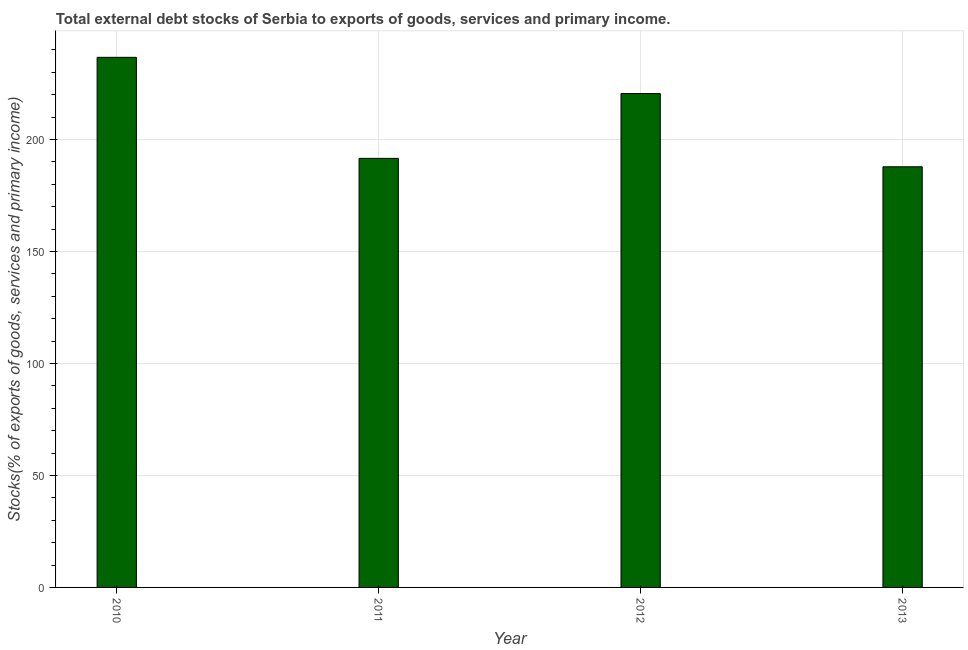Does the graph contain grids?
Give a very brief answer. Yes. What is the title of the graph?
Offer a very short reply. Total external debt stocks of Serbia to exports of goods, services and primary income. What is the label or title of the Y-axis?
Ensure brevity in your answer.  Stocks(% of exports of goods, services and primary income). What is the external debt stocks in 2013?
Offer a terse response. 187.8. Across all years, what is the maximum external debt stocks?
Keep it short and to the point. 236.67. Across all years, what is the minimum external debt stocks?
Provide a succinct answer. 187.8. In which year was the external debt stocks maximum?
Make the answer very short. 2010. What is the sum of the external debt stocks?
Provide a short and direct response. 836.52. What is the difference between the external debt stocks in 2010 and 2013?
Give a very brief answer. 48.87. What is the average external debt stocks per year?
Give a very brief answer. 209.13. What is the median external debt stocks?
Offer a terse response. 206.03. What is the ratio of the external debt stocks in 2010 to that in 2013?
Provide a succinct answer. 1.26. Is the external debt stocks in 2010 less than that in 2011?
Your response must be concise. No. Is the difference between the external debt stocks in 2010 and 2011 greater than the difference between any two years?
Make the answer very short. No. What is the difference between the highest and the second highest external debt stocks?
Make the answer very short. 16.17. Is the sum of the external debt stocks in 2010 and 2013 greater than the maximum external debt stocks across all years?
Offer a very short reply. Yes. What is the difference between the highest and the lowest external debt stocks?
Give a very brief answer. 48.87. In how many years, is the external debt stocks greater than the average external debt stocks taken over all years?
Give a very brief answer. 2. Are all the bars in the graph horizontal?
Your response must be concise. No. How many years are there in the graph?
Offer a terse response. 4. What is the Stocks(% of exports of goods, services and primary income) of 2010?
Give a very brief answer. 236.67. What is the Stocks(% of exports of goods, services and primary income) of 2011?
Give a very brief answer. 191.56. What is the Stocks(% of exports of goods, services and primary income) of 2012?
Your response must be concise. 220.5. What is the Stocks(% of exports of goods, services and primary income) in 2013?
Keep it short and to the point. 187.8. What is the difference between the Stocks(% of exports of goods, services and primary income) in 2010 and 2011?
Provide a succinct answer. 45.11. What is the difference between the Stocks(% of exports of goods, services and primary income) in 2010 and 2012?
Ensure brevity in your answer.  16.17. What is the difference between the Stocks(% of exports of goods, services and primary income) in 2010 and 2013?
Give a very brief answer. 48.87. What is the difference between the Stocks(% of exports of goods, services and primary income) in 2011 and 2012?
Offer a very short reply. -28.94. What is the difference between the Stocks(% of exports of goods, services and primary income) in 2011 and 2013?
Offer a very short reply. 3.76. What is the difference between the Stocks(% of exports of goods, services and primary income) in 2012 and 2013?
Ensure brevity in your answer.  32.7. What is the ratio of the Stocks(% of exports of goods, services and primary income) in 2010 to that in 2011?
Your answer should be compact. 1.24. What is the ratio of the Stocks(% of exports of goods, services and primary income) in 2010 to that in 2012?
Ensure brevity in your answer.  1.07. What is the ratio of the Stocks(% of exports of goods, services and primary income) in 2010 to that in 2013?
Your answer should be compact. 1.26. What is the ratio of the Stocks(% of exports of goods, services and primary income) in 2011 to that in 2012?
Your answer should be compact. 0.87. What is the ratio of the Stocks(% of exports of goods, services and primary income) in 2012 to that in 2013?
Your answer should be compact. 1.17. 